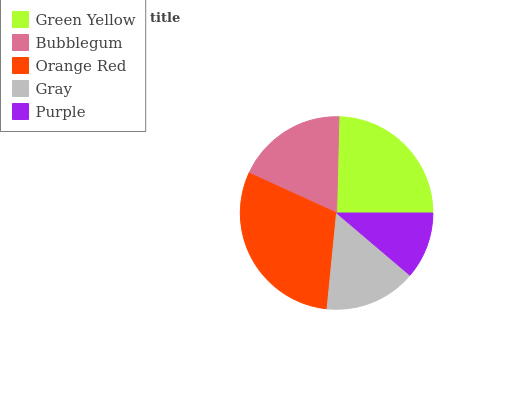Is Purple the minimum?
Answer yes or no. Yes. Is Orange Red the maximum?
Answer yes or no. Yes. Is Bubblegum the minimum?
Answer yes or no. No. Is Bubblegum the maximum?
Answer yes or no. No. Is Green Yellow greater than Bubblegum?
Answer yes or no. Yes. Is Bubblegum less than Green Yellow?
Answer yes or no. Yes. Is Bubblegum greater than Green Yellow?
Answer yes or no. No. Is Green Yellow less than Bubblegum?
Answer yes or no. No. Is Bubblegum the high median?
Answer yes or no. Yes. Is Bubblegum the low median?
Answer yes or no. Yes. Is Purple the high median?
Answer yes or no. No. Is Orange Red the low median?
Answer yes or no. No. 